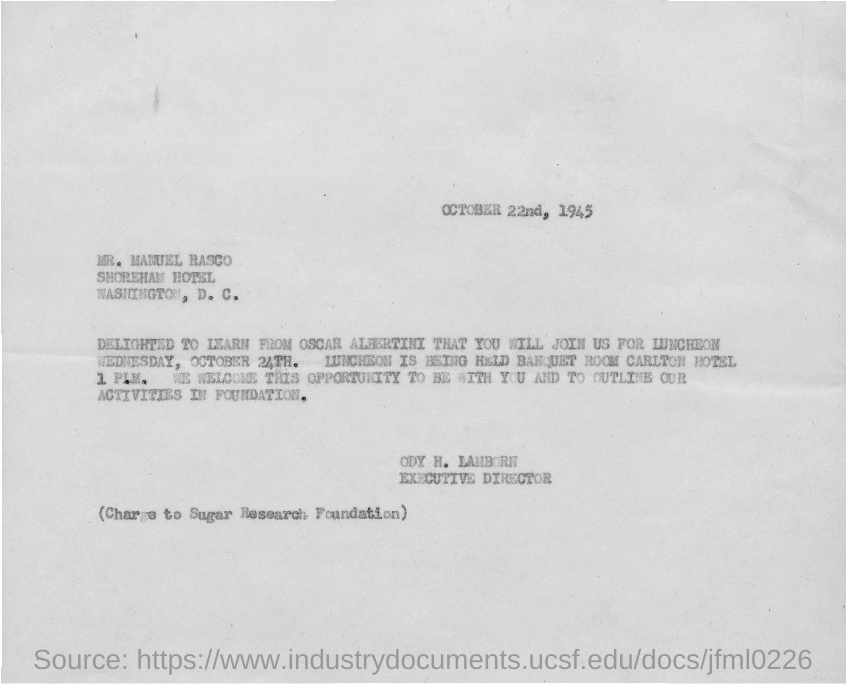Who is the sender of this document?
Offer a terse response. ODY H. LAMBORN. What is the deisgnation of ODY H. LAMBORN?
Offer a very short reply. Executive director. To whom, the document is addressed?
Your answer should be compact. MR. MANUEL RASCO. 